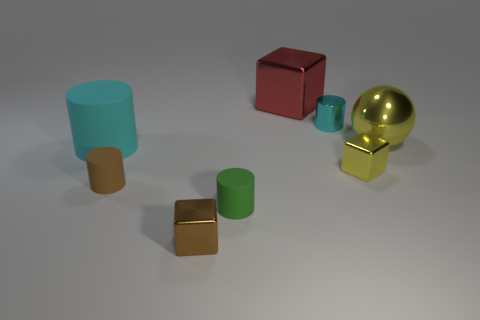How many tiny things are both in front of the tiny brown matte thing and behind the large cyan thing?
Provide a succinct answer. 0. Are there fewer green rubber cylinders on the left side of the tiny brown block than large cyan matte things?
Keep it short and to the point. Yes. Are there any brown metal things of the same size as the green rubber object?
Your response must be concise. Yes. The tiny cylinder that is the same material as the small green object is what color?
Provide a short and direct response. Brown. How many metallic objects are on the left side of the tiny thing behind the big cylinder?
Ensure brevity in your answer.  2. What material is the cube that is behind the small brown block and in front of the large yellow shiny thing?
Provide a short and direct response. Metal. Is the shape of the yellow metallic thing that is to the left of the metal sphere the same as  the brown metallic thing?
Your answer should be compact. Yes. Are there fewer blocks than big rubber cylinders?
Your answer should be very brief. No. How many big matte cylinders have the same color as the metallic cylinder?
Offer a terse response. 1. What is the material of the thing that is the same color as the metal cylinder?
Provide a short and direct response. Rubber. 